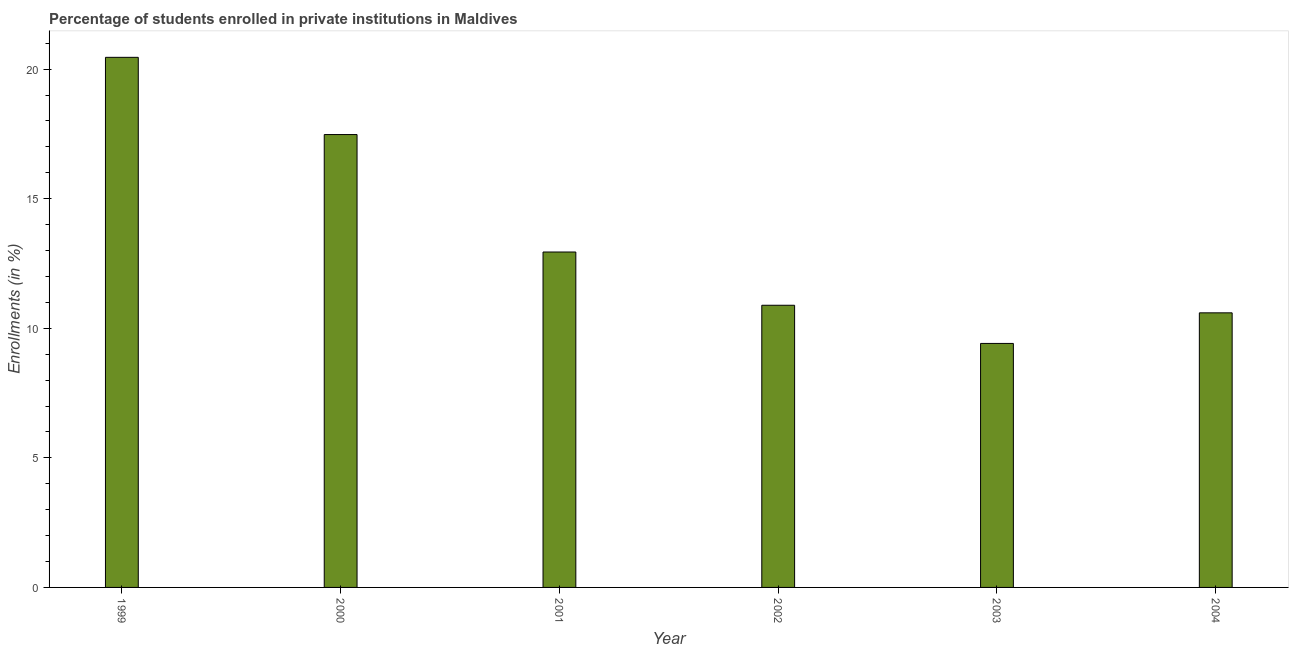Does the graph contain any zero values?
Make the answer very short. No. Does the graph contain grids?
Offer a very short reply. No. What is the title of the graph?
Offer a very short reply. Percentage of students enrolled in private institutions in Maldives. What is the label or title of the Y-axis?
Your response must be concise. Enrollments (in %). What is the enrollments in private institutions in 2000?
Ensure brevity in your answer.  17.48. Across all years, what is the maximum enrollments in private institutions?
Make the answer very short. 20.46. Across all years, what is the minimum enrollments in private institutions?
Give a very brief answer. 9.42. In which year was the enrollments in private institutions minimum?
Offer a terse response. 2003. What is the sum of the enrollments in private institutions?
Give a very brief answer. 81.78. What is the difference between the enrollments in private institutions in 2001 and 2004?
Keep it short and to the point. 2.35. What is the average enrollments in private institutions per year?
Provide a succinct answer. 13.63. What is the median enrollments in private institutions?
Ensure brevity in your answer.  11.92. What is the ratio of the enrollments in private institutions in 2000 to that in 2003?
Your answer should be very brief. 1.86. What is the difference between the highest and the second highest enrollments in private institutions?
Ensure brevity in your answer.  2.98. What is the difference between the highest and the lowest enrollments in private institutions?
Provide a succinct answer. 11.04. In how many years, is the enrollments in private institutions greater than the average enrollments in private institutions taken over all years?
Your response must be concise. 2. How many bars are there?
Provide a short and direct response. 6. How many years are there in the graph?
Your answer should be very brief. 6. What is the difference between two consecutive major ticks on the Y-axis?
Give a very brief answer. 5. Are the values on the major ticks of Y-axis written in scientific E-notation?
Your response must be concise. No. What is the Enrollments (in %) of 1999?
Your response must be concise. 20.46. What is the Enrollments (in %) of 2000?
Your answer should be compact. 17.48. What is the Enrollments (in %) of 2001?
Your response must be concise. 12.94. What is the Enrollments (in %) in 2002?
Offer a very short reply. 10.89. What is the Enrollments (in %) of 2003?
Your response must be concise. 9.42. What is the Enrollments (in %) of 2004?
Your answer should be compact. 10.6. What is the difference between the Enrollments (in %) in 1999 and 2000?
Your response must be concise. 2.98. What is the difference between the Enrollments (in %) in 1999 and 2001?
Your answer should be very brief. 7.51. What is the difference between the Enrollments (in %) in 1999 and 2002?
Your response must be concise. 9.57. What is the difference between the Enrollments (in %) in 1999 and 2003?
Provide a succinct answer. 11.04. What is the difference between the Enrollments (in %) in 1999 and 2004?
Give a very brief answer. 9.86. What is the difference between the Enrollments (in %) in 2000 and 2001?
Your answer should be compact. 4.53. What is the difference between the Enrollments (in %) in 2000 and 2002?
Your answer should be very brief. 6.59. What is the difference between the Enrollments (in %) in 2000 and 2003?
Provide a succinct answer. 8.06. What is the difference between the Enrollments (in %) in 2000 and 2004?
Give a very brief answer. 6.88. What is the difference between the Enrollments (in %) in 2001 and 2002?
Provide a short and direct response. 2.05. What is the difference between the Enrollments (in %) in 2001 and 2003?
Your answer should be compact. 3.53. What is the difference between the Enrollments (in %) in 2001 and 2004?
Your answer should be compact. 2.35. What is the difference between the Enrollments (in %) in 2002 and 2003?
Your response must be concise. 1.47. What is the difference between the Enrollments (in %) in 2002 and 2004?
Offer a terse response. 0.29. What is the difference between the Enrollments (in %) in 2003 and 2004?
Your answer should be compact. -1.18. What is the ratio of the Enrollments (in %) in 1999 to that in 2000?
Provide a succinct answer. 1.17. What is the ratio of the Enrollments (in %) in 1999 to that in 2001?
Offer a terse response. 1.58. What is the ratio of the Enrollments (in %) in 1999 to that in 2002?
Give a very brief answer. 1.88. What is the ratio of the Enrollments (in %) in 1999 to that in 2003?
Your response must be concise. 2.17. What is the ratio of the Enrollments (in %) in 1999 to that in 2004?
Your answer should be compact. 1.93. What is the ratio of the Enrollments (in %) in 2000 to that in 2001?
Give a very brief answer. 1.35. What is the ratio of the Enrollments (in %) in 2000 to that in 2002?
Provide a succinct answer. 1.6. What is the ratio of the Enrollments (in %) in 2000 to that in 2003?
Provide a short and direct response. 1.86. What is the ratio of the Enrollments (in %) in 2000 to that in 2004?
Offer a very short reply. 1.65. What is the ratio of the Enrollments (in %) in 2001 to that in 2002?
Give a very brief answer. 1.19. What is the ratio of the Enrollments (in %) in 2001 to that in 2003?
Keep it short and to the point. 1.38. What is the ratio of the Enrollments (in %) in 2001 to that in 2004?
Provide a succinct answer. 1.22. What is the ratio of the Enrollments (in %) in 2002 to that in 2003?
Your answer should be compact. 1.16. What is the ratio of the Enrollments (in %) in 2002 to that in 2004?
Keep it short and to the point. 1.03. What is the ratio of the Enrollments (in %) in 2003 to that in 2004?
Your answer should be compact. 0.89. 